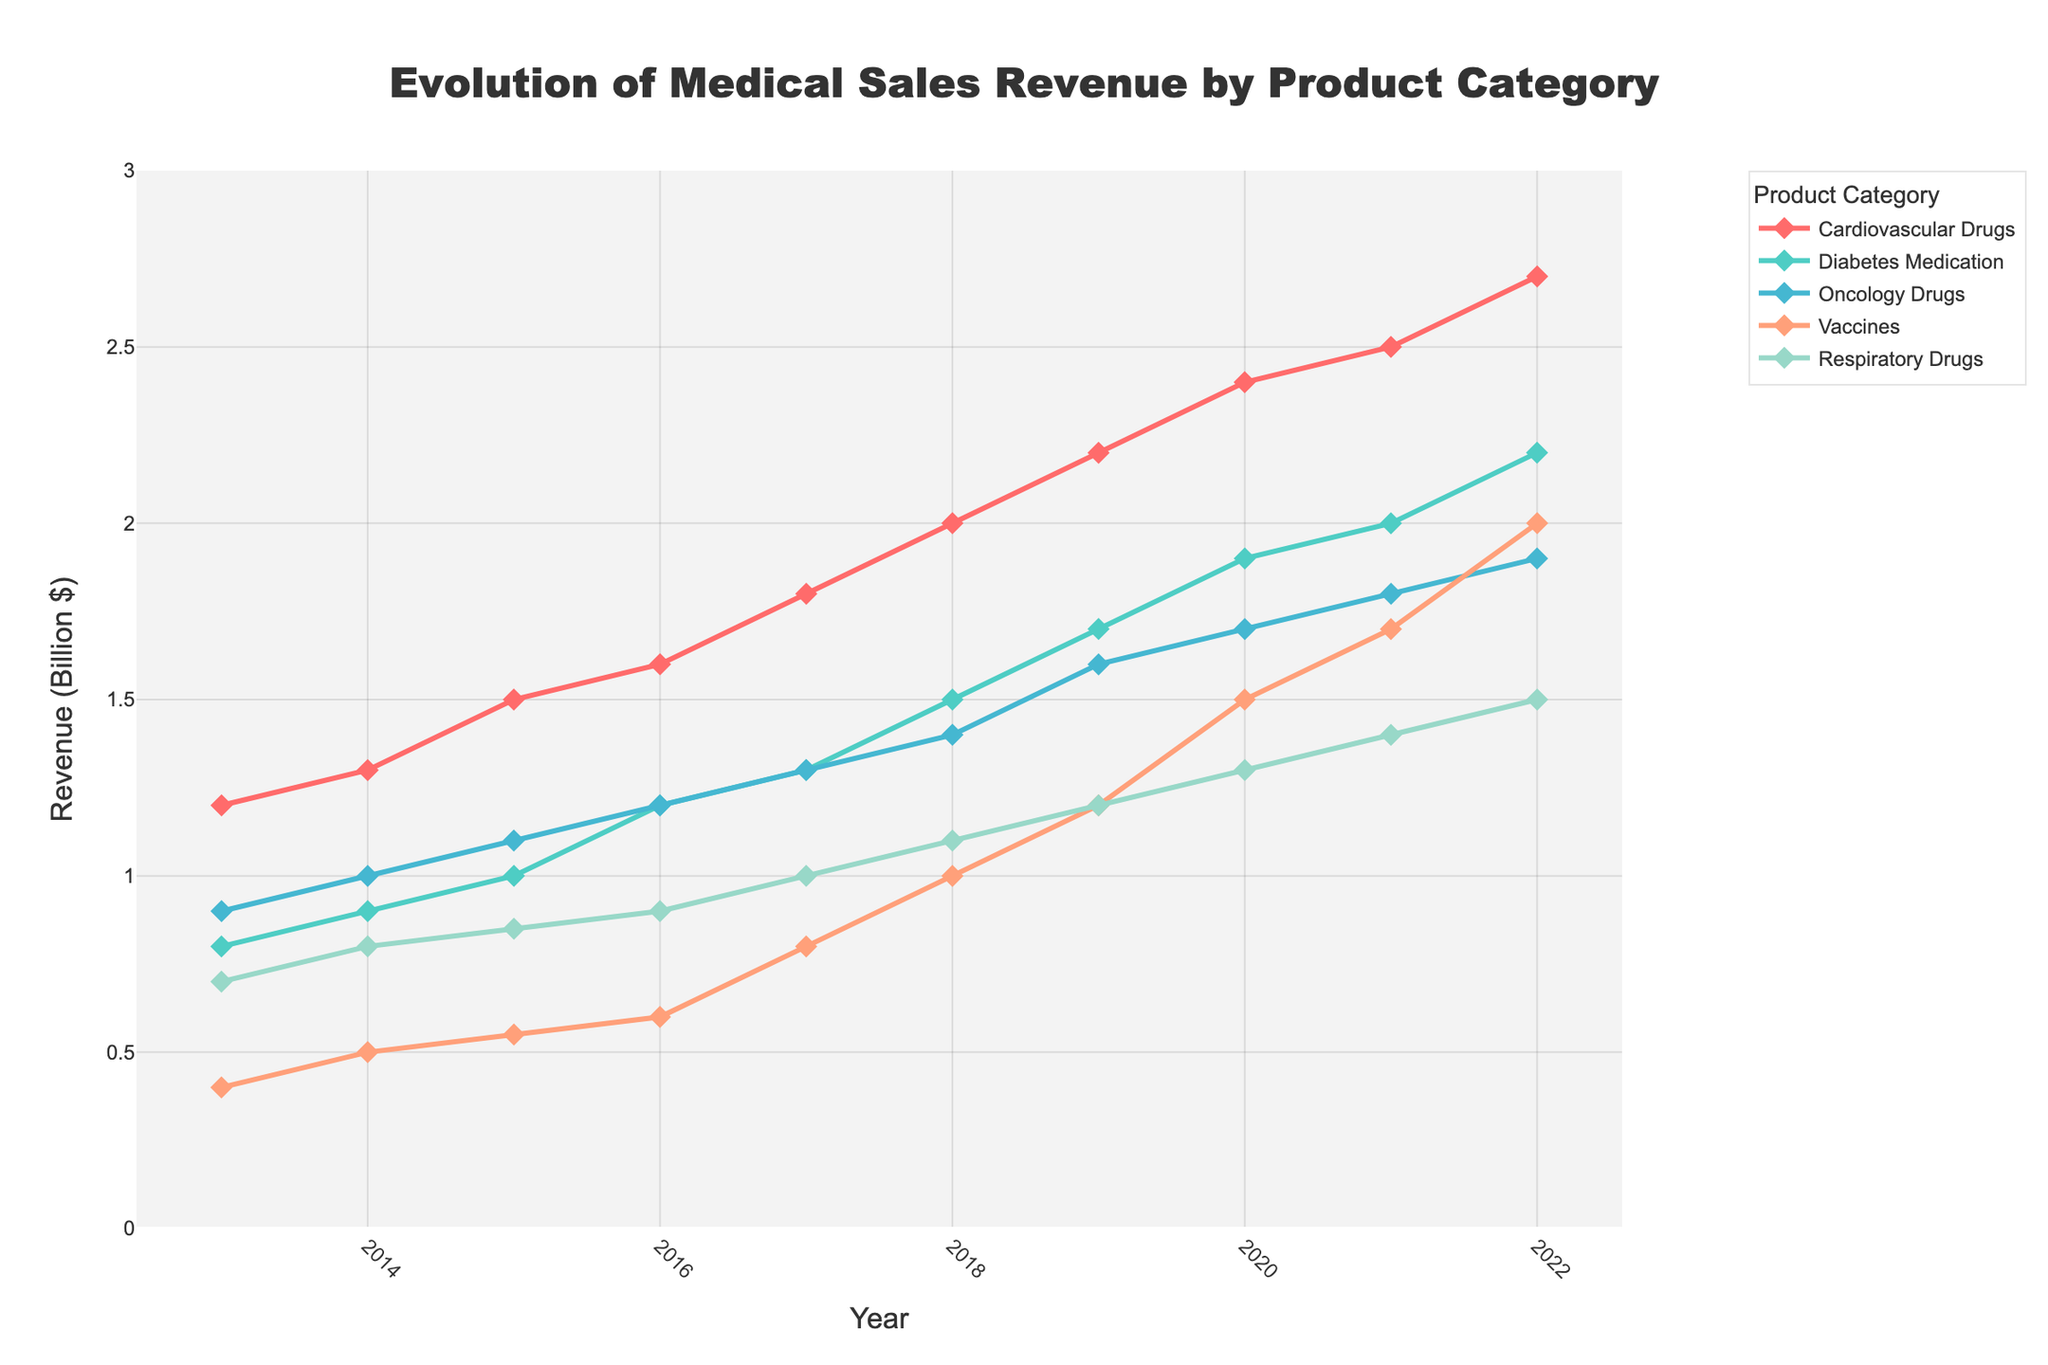How many product categories are represented in the figure? Count the distinct product categories listed in the legend.
Answer: 5 Which product category had the highest revenue in 2022? Look at the data points for each category in the year 2022 and determine which one is the highest.
Answer: Cardiovascular Drugs What was the revenue of Oncology Drugs in 2015? Find the 2015 data point for Oncology Drugs on the plot.
Answer: 1.1 billion $ How did the revenue of Vaccines change from 2016 to 2019? Calculate the difference in revenue from 2016 to 2019 for Vaccines: 1.2 - 0.6.
Answer: Increased by 0.6 billion $ Which product category had the smallest increase in revenue from 2013 to 2022? Calculate the difference for each category from 2013 to 2022 and find the smallest one.
Answer: Respiratory Drugs Comparing Cardiovascular Drugs and Diabetes Medication, which category had a greater increase in revenue from 2013 to 2022? Calculate the increase for each: Cardiovascular Drugs (2.7 - 1.2) and Diabetes Medication (2.2 - 0.8) and compare.
Answer: Cardiovascular Drugs (1.5 billion $) What is the overall trend of revenue for Respiratory Drugs over the last decade? Analyze the plot line for Respiratory Drugs from 2013 to 2022.
Answer: Increasing Are there any years where all product categories showed an increase in revenue compared to the previous year? Examine each year and check if the revenue for all categories is higher than the previous year.
Answer: Yes, 2014, 2015, 2018, 2019, 2020, 2021, and 2022 In which year did Diabetes Medication see the most significant increase in revenue compared to the previous year? Calculate the yearly differences and find the maximum increase for Diabetes Medication.
Answer: 2016 Which two product categories had the closest revenue values in 2021? Compare the 2021 revenue values for each pair of categories to find the smallest difference.
Answer: Oncology Drugs and Vaccines (both have a revenue of 1.7 billion $) 